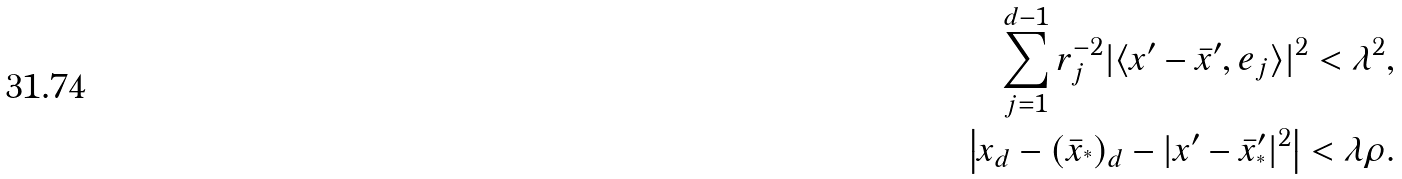Convert formula to latex. <formula><loc_0><loc_0><loc_500><loc_500>\sum _ { j = 1 } ^ { d - 1 } r _ { j } ^ { - 2 } | \langle x ^ { \prime } - \bar { x } ^ { \prime } , e _ { j } \rangle | ^ { 2 } < \lambda ^ { 2 } , \\ \left | x _ { d } - ( \bar { x } _ { ^ { * } } ) _ { d } - | x ^ { \prime } - \bar { x } _ { ^ { * } } ^ { \prime } | ^ { 2 } \right | < \lambda \rho .</formula> 